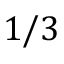Convert formula to latex. <formula><loc_0><loc_0><loc_500><loc_500>1 / 3</formula> 